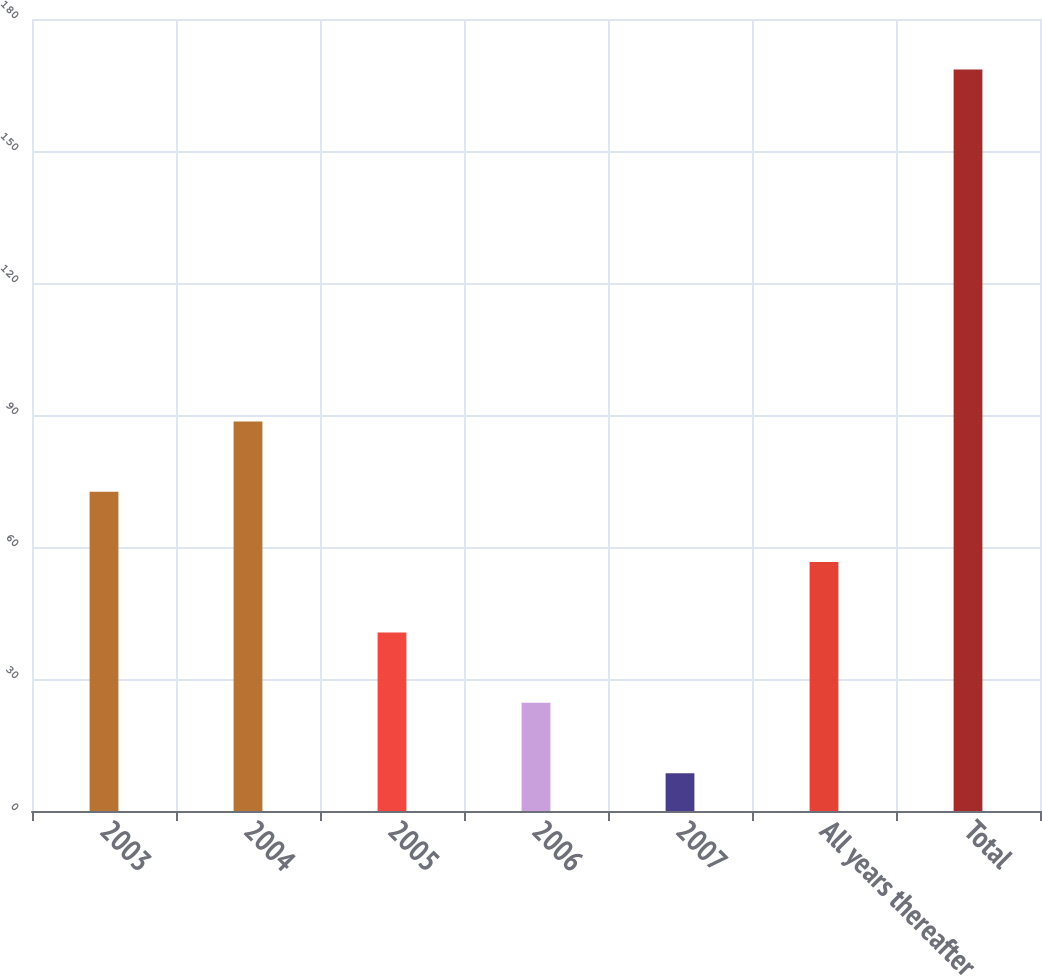<chart> <loc_0><loc_0><loc_500><loc_500><bar_chart><fcel>2003<fcel>2004<fcel>2005<fcel>2006<fcel>2007<fcel>All years thereafter<fcel>Total<nl><fcel>72.56<fcel>88.55<fcel>40.58<fcel>24.59<fcel>8.6<fcel>56.57<fcel>168.5<nl></chart> 